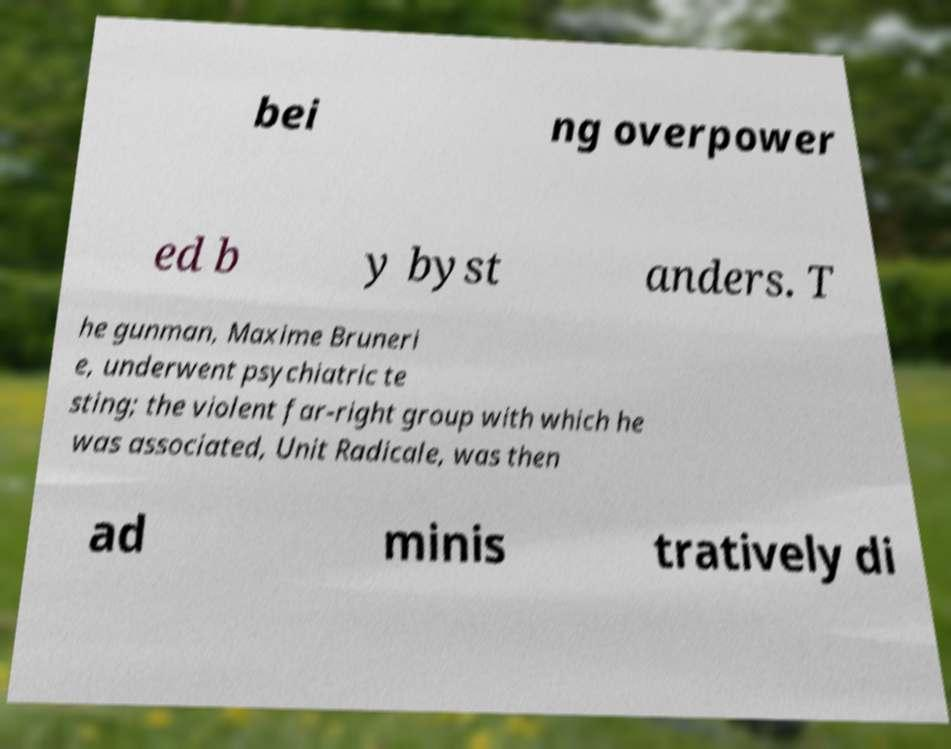Can you read and provide the text displayed in the image?This photo seems to have some interesting text. Can you extract and type it out for me? bei ng overpower ed b y byst anders. T he gunman, Maxime Bruneri e, underwent psychiatric te sting; the violent far-right group with which he was associated, Unit Radicale, was then ad minis tratively di 